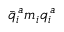Convert formula to latex. <formula><loc_0><loc_0><loc_500><loc_500>\bar { q } _ { i } ^ { \, a } m _ { i } q _ { i } ^ { \, a }</formula> 